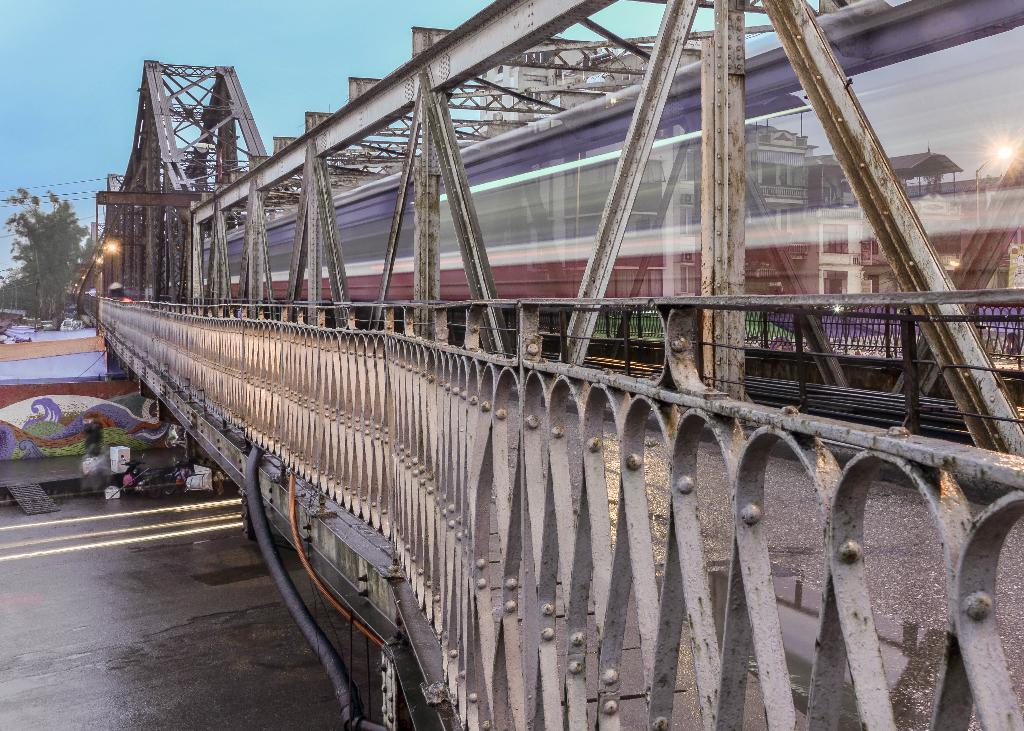What type of bridge is shown in the image? There is a bridge made of metal in the image. What is located at the bottom of the image? There is a road at the bottom of the image. What can be seen to the right of the image? There appears to be a train to the right of the image. What is located to the left of the image? There is a tree to the left of the image. What is visible at the top of the image? The sky is visible at the top of the image. What season is depicted in the image? The provided facts do not mention any specific season or time of year, so it cannot be determined from the image. What level of difficulty is the bridge designed for? The image does not provide any information about the bridge's difficulty level, as it only shows the bridge's appearance. 